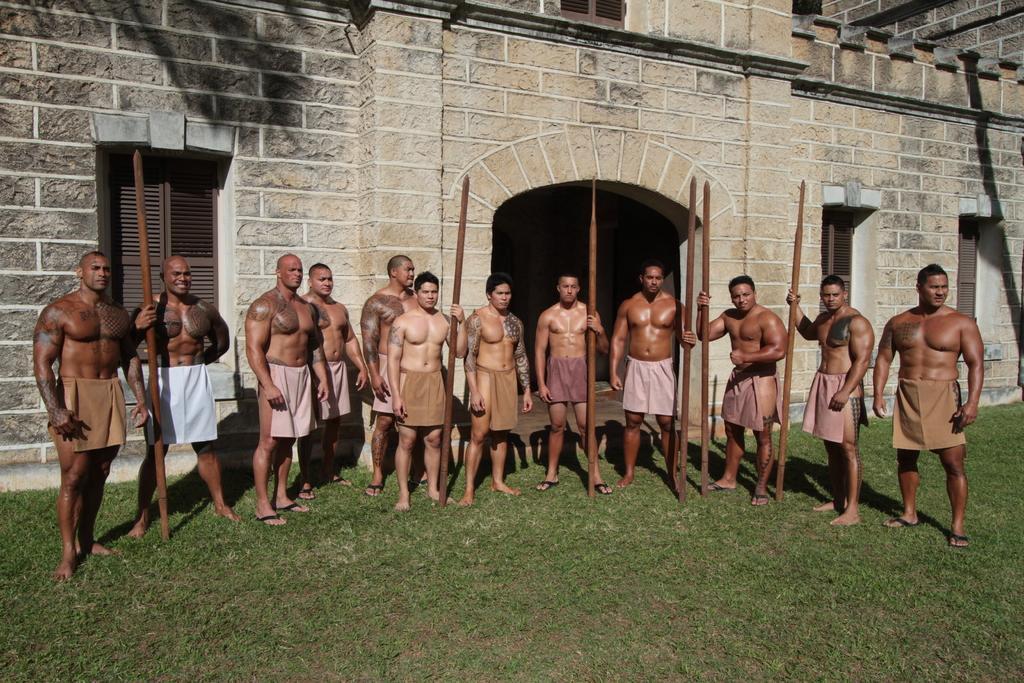In one or two sentences, can you explain what this image depicts? Here we can see few persons are standing on the ground. This is grass. In the background there is a building. 